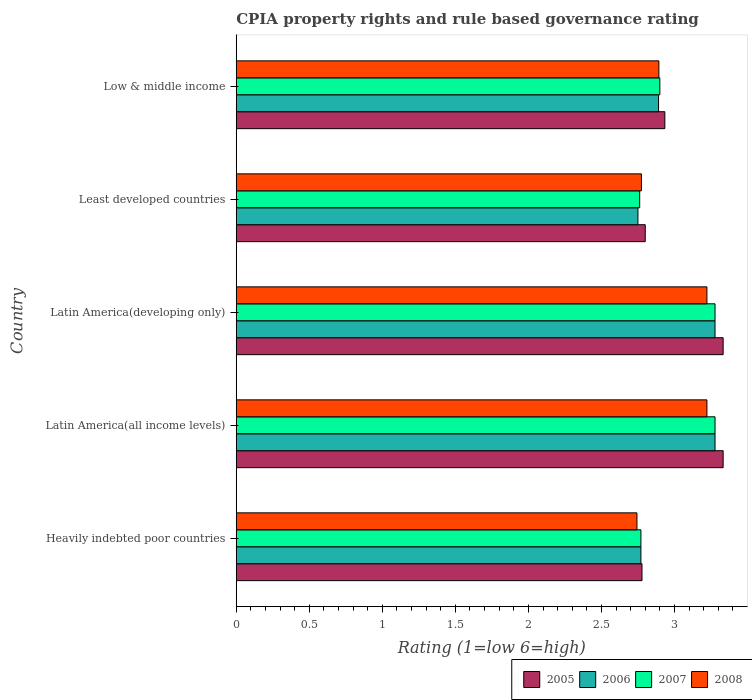How many different coloured bars are there?
Provide a short and direct response. 4. How many groups of bars are there?
Keep it short and to the point. 5. Are the number of bars on each tick of the Y-axis equal?
Provide a short and direct response. Yes. How many bars are there on the 2nd tick from the top?
Provide a short and direct response. 4. How many bars are there on the 3rd tick from the bottom?
Offer a terse response. 4. What is the label of the 4th group of bars from the top?
Keep it short and to the point. Latin America(all income levels). In how many cases, is the number of bars for a given country not equal to the number of legend labels?
Ensure brevity in your answer.  0. What is the CPIA rating in 2006 in Latin America(all income levels)?
Provide a succinct answer. 3.28. Across all countries, what is the maximum CPIA rating in 2006?
Offer a very short reply. 3.28. Across all countries, what is the minimum CPIA rating in 2006?
Provide a short and direct response. 2.75. In which country was the CPIA rating in 2006 maximum?
Your response must be concise. Latin America(all income levels). In which country was the CPIA rating in 2007 minimum?
Offer a terse response. Least developed countries. What is the total CPIA rating in 2006 in the graph?
Your answer should be compact. 14.97. What is the difference between the CPIA rating in 2005 in Heavily indebted poor countries and that in Latin America(developing only)?
Give a very brief answer. -0.56. What is the difference between the CPIA rating in 2005 in Heavily indebted poor countries and the CPIA rating in 2006 in Latin America(developing only)?
Your answer should be very brief. -0.5. What is the average CPIA rating in 2006 per country?
Your answer should be very brief. 2.99. What is the difference between the CPIA rating in 2005 and CPIA rating in 2008 in Latin America(all income levels)?
Provide a short and direct response. 0.11. In how many countries, is the CPIA rating in 2006 greater than 2.5 ?
Provide a succinct answer. 5. What is the ratio of the CPIA rating in 2005 in Heavily indebted poor countries to that in Latin America(developing only)?
Give a very brief answer. 0.83. Is the CPIA rating in 2008 in Latin America(developing only) less than that in Least developed countries?
Keep it short and to the point. No. Is the difference between the CPIA rating in 2005 in Least developed countries and Low & middle income greater than the difference between the CPIA rating in 2008 in Least developed countries and Low & middle income?
Your answer should be compact. No. What is the difference between the highest and the lowest CPIA rating in 2007?
Your answer should be compact. 0.52. Is the sum of the CPIA rating in 2005 in Latin America(all income levels) and Latin America(developing only) greater than the maximum CPIA rating in 2008 across all countries?
Your response must be concise. Yes. Is it the case that in every country, the sum of the CPIA rating in 2006 and CPIA rating in 2008 is greater than the sum of CPIA rating in 2005 and CPIA rating in 2007?
Your answer should be very brief. No. Is it the case that in every country, the sum of the CPIA rating in 2005 and CPIA rating in 2006 is greater than the CPIA rating in 2008?
Offer a very short reply. Yes. How many bars are there?
Provide a succinct answer. 20. How many countries are there in the graph?
Ensure brevity in your answer.  5. Are the values on the major ticks of X-axis written in scientific E-notation?
Ensure brevity in your answer.  No. Does the graph contain grids?
Offer a terse response. No. How many legend labels are there?
Your response must be concise. 4. How are the legend labels stacked?
Ensure brevity in your answer.  Horizontal. What is the title of the graph?
Make the answer very short. CPIA property rights and rule based governance rating. Does "1994" appear as one of the legend labels in the graph?
Offer a very short reply. No. What is the label or title of the X-axis?
Provide a succinct answer. Rating (1=low 6=high). What is the Rating (1=low 6=high) of 2005 in Heavily indebted poor countries?
Give a very brief answer. 2.78. What is the Rating (1=low 6=high) in 2006 in Heavily indebted poor countries?
Give a very brief answer. 2.77. What is the Rating (1=low 6=high) in 2007 in Heavily indebted poor countries?
Provide a succinct answer. 2.77. What is the Rating (1=low 6=high) in 2008 in Heavily indebted poor countries?
Your answer should be compact. 2.74. What is the Rating (1=low 6=high) in 2005 in Latin America(all income levels)?
Offer a terse response. 3.33. What is the Rating (1=low 6=high) in 2006 in Latin America(all income levels)?
Your answer should be very brief. 3.28. What is the Rating (1=low 6=high) of 2007 in Latin America(all income levels)?
Offer a terse response. 3.28. What is the Rating (1=low 6=high) in 2008 in Latin America(all income levels)?
Ensure brevity in your answer.  3.22. What is the Rating (1=low 6=high) of 2005 in Latin America(developing only)?
Your response must be concise. 3.33. What is the Rating (1=low 6=high) in 2006 in Latin America(developing only)?
Your answer should be very brief. 3.28. What is the Rating (1=low 6=high) of 2007 in Latin America(developing only)?
Offer a terse response. 3.28. What is the Rating (1=low 6=high) of 2008 in Latin America(developing only)?
Your response must be concise. 3.22. What is the Rating (1=low 6=high) of 2005 in Least developed countries?
Your response must be concise. 2.8. What is the Rating (1=low 6=high) in 2006 in Least developed countries?
Your answer should be compact. 2.75. What is the Rating (1=low 6=high) in 2007 in Least developed countries?
Offer a terse response. 2.76. What is the Rating (1=low 6=high) in 2008 in Least developed countries?
Offer a terse response. 2.77. What is the Rating (1=low 6=high) in 2005 in Low & middle income?
Ensure brevity in your answer.  2.93. What is the Rating (1=low 6=high) in 2006 in Low & middle income?
Your answer should be compact. 2.89. What is the Rating (1=low 6=high) in 2008 in Low & middle income?
Offer a terse response. 2.89. Across all countries, what is the maximum Rating (1=low 6=high) of 2005?
Offer a very short reply. 3.33. Across all countries, what is the maximum Rating (1=low 6=high) of 2006?
Offer a terse response. 3.28. Across all countries, what is the maximum Rating (1=low 6=high) in 2007?
Provide a succinct answer. 3.28. Across all countries, what is the maximum Rating (1=low 6=high) in 2008?
Offer a terse response. 3.22. Across all countries, what is the minimum Rating (1=low 6=high) in 2005?
Ensure brevity in your answer.  2.78. Across all countries, what is the minimum Rating (1=low 6=high) in 2006?
Provide a succinct answer. 2.75. Across all countries, what is the minimum Rating (1=low 6=high) of 2007?
Your answer should be compact. 2.76. Across all countries, what is the minimum Rating (1=low 6=high) in 2008?
Your answer should be compact. 2.74. What is the total Rating (1=low 6=high) in 2005 in the graph?
Give a very brief answer. 15.18. What is the total Rating (1=low 6=high) of 2006 in the graph?
Provide a short and direct response. 14.97. What is the total Rating (1=low 6=high) in 2007 in the graph?
Offer a terse response. 14.99. What is the total Rating (1=low 6=high) in 2008 in the graph?
Your answer should be very brief. 14.85. What is the difference between the Rating (1=low 6=high) in 2005 in Heavily indebted poor countries and that in Latin America(all income levels)?
Provide a succinct answer. -0.56. What is the difference between the Rating (1=low 6=high) in 2006 in Heavily indebted poor countries and that in Latin America(all income levels)?
Keep it short and to the point. -0.51. What is the difference between the Rating (1=low 6=high) in 2007 in Heavily indebted poor countries and that in Latin America(all income levels)?
Offer a very short reply. -0.51. What is the difference between the Rating (1=low 6=high) in 2008 in Heavily indebted poor countries and that in Latin America(all income levels)?
Your answer should be compact. -0.48. What is the difference between the Rating (1=low 6=high) of 2005 in Heavily indebted poor countries and that in Latin America(developing only)?
Make the answer very short. -0.56. What is the difference between the Rating (1=low 6=high) in 2006 in Heavily indebted poor countries and that in Latin America(developing only)?
Keep it short and to the point. -0.51. What is the difference between the Rating (1=low 6=high) in 2007 in Heavily indebted poor countries and that in Latin America(developing only)?
Your answer should be compact. -0.51. What is the difference between the Rating (1=low 6=high) of 2008 in Heavily indebted poor countries and that in Latin America(developing only)?
Keep it short and to the point. -0.48. What is the difference between the Rating (1=low 6=high) of 2005 in Heavily indebted poor countries and that in Least developed countries?
Offer a very short reply. -0.02. What is the difference between the Rating (1=low 6=high) of 2006 in Heavily indebted poor countries and that in Least developed countries?
Provide a succinct answer. 0.02. What is the difference between the Rating (1=low 6=high) of 2007 in Heavily indebted poor countries and that in Least developed countries?
Your answer should be very brief. 0.01. What is the difference between the Rating (1=low 6=high) of 2008 in Heavily indebted poor countries and that in Least developed countries?
Offer a terse response. -0.03. What is the difference between the Rating (1=low 6=high) of 2005 in Heavily indebted poor countries and that in Low & middle income?
Your answer should be very brief. -0.16. What is the difference between the Rating (1=low 6=high) of 2006 in Heavily indebted poor countries and that in Low & middle income?
Ensure brevity in your answer.  -0.12. What is the difference between the Rating (1=low 6=high) in 2007 in Heavily indebted poor countries and that in Low & middle income?
Make the answer very short. -0.13. What is the difference between the Rating (1=low 6=high) in 2008 in Heavily indebted poor countries and that in Low & middle income?
Provide a short and direct response. -0.15. What is the difference between the Rating (1=low 6=high) of 2005 in Latin America(all income levels) and that in Latin America(developing only)?
Offer a very short reply. 0. What is the difference between the Rating (1=low 6=high) of 2006 in Latin America(all income levels) and that in Latin America(developing only)?
Provide a short and direct response. 0. What is the difference between the Rating (1=low 6=high) in 2007 in Latin America(all income levels) and that in Latin America(developing only)?
Give a very brief answer. 0. What is the difference between the Rating (1=low 6=high) of 2005 in Latin America(all income levels) and that in Least developed countries?
Ensure brevity in your answer.  0.53. What is the difference between the Rating (1=low 6=high) of 2006 in Latin America(all income levels) and that in Least developed countries?
Provide a succinct answer. 0.53. What is the difference between the Rating (1=low 6=high) of 2007 in Latin America(all income levels) and that in Least developed countries?
Offer a terse response. 0.52. What is the difference between the Rating (1=low 6=high) of 2008 in Latin America(all income levels) and that in Least developed countries?
Your answer should be compact. 0.45. What is the difference between the Rating (1=low 6=high) of 2005 in Latin America(all income levels) and that in Low & middle income?
Ensure brevity in your answer.  0.4. What is the difference between the Rating (1=low 6=high) of 2006 in Latin America(all income levels) and that in Low & middle income?
Give a very brief answer. 0.39. What is the difference between the Rating (1=low 6=high) of 2007 in Latin America(all income levels) and that in Low & middle income?
Your answer should be compact. 0.38. What is the difference between the Rating (1=low 6=high) in 2008 in Latin America(all income levels) and that in Low & middle income?
Make the answer very short. 0.33. What is the difference between the Rating (1=low 6=high) of 2005 in Latin America(developing only) and that in Least developed countries?
Provide a short and direct response. 0.53. What is the difference between the Rating (1=low 6=high) in 2006 in Latin America(developing only) and that in Least developed countries?
Your answer should be compact. 0.53. What is the difference between the Rating (1=low 6=high) in 2007 in Latin America(developing only) and that in Least developed countries?
Provide a succinct answer. 0.52. What is the difference between the Rating (1=low 6=high) of 2008 in Latin America(developing only) and that in Least developed countries?
Keep it short and to the point. 0.45. What is the difference between the Rating (1=low 6=high) of 2005 in Latin America(developing only) and that in Low & middle income?
Give a very brief answer. 0.4. What is the difference between the Rating (1=low 6=high) of 2006 in Latin America(developing only) and that in Low & middle income?
Offer a very short reply. 0.39. What is the difference between the Rating (1=low 6=high) of 2007 in Latin America(developing only) and that in Low & middle income?
Offer a very short reply. 0.38. What is the difference between the Rating (1=low 6=high) in 2008 in Latin America(developing only) and that in Low & middle income?
Make the answer very short. 0.33. What is the difference between the Rating (1=low 6=high) in 2005 in Least developed countries and that in Low & middle income?
Offer a terse response. -0.13. What is the difference between the Rating (1=low 6=high) of 2006 in Least developed countries and that in Low & middle income?
Your answer should be very brief. -0.14. What is the difference between the Rating (1=low 6=high) in 2007 in Least developed countries and that in Low & middle income?
Offer a very short reply. -0.14. What is the difference between the Rating (1=low 6=high) in 2008 in Least developed countries and that in Low & middle income?
Your response must be concise. -0.12. What is the difference between the Rating (1=low 6=high) of 2005 in Heavily indebted poor countries and the Rating (1=low 6=high) of 2007 in Latin America(all income levels)?
Your answer should be very brief. -0.5. What is the difference between the Rating (1=low 6=high) in 2005 in Heavily indebted poor countries and the Rating (1=low 6=high) in 2008 in Latin America(all income levels)?
Offer a very short reply. -0.44. What is the difference between the Rating (1=low 6=high) in 2006 in Heavily indebted poor countries and the Rating (1=low 6=high) in 2007 in Latin America(all income levels)?
Offer a very short reply. -0.51. What is the difference between the Rating (1=low 6=high) of 2006 in Heavily indebted poor countries and the Rating (1=low 6=high) of 2008 in Latin America(all income levels)?
Your answer should be very brief. -0.45. What is the difference between the Rating (1=low 6=high) in 2007 in Heavily indebted poor countries and the Rating (1=low 6=high) in 2008 in Latin America(all income levels)?
Offer a terse response. -0.45. What is the difference between the Rating (1=low 6=high) in 2005 in Heavily indebted poor countries and the Rating (1=low 6=high) in 2007 in Latin America(developing only)?
Give a very brief answer. -0.5. What is the difference between the Rating (1=low 6=high) in 2005 in Heavily indebted poor countries and the Rating (1=low 6=high) in 2008 in Latin America(developing only)?
Give a very brief answer. -0.44. What is the difference between the Rating (1=low 6=high) of 2006 in Heavily indebted poor countries and the Rating (1=low 6=high) of 2007 in Latin America(developing only)?
Provide a succinct answer. -0.51. What is the difference between the Rating (1=low 6=high) in 2006 in Heavily indebted poor countries and the Rating (1=low 6=high) in 2008 in Latin America(developing only)?
Your response must be concise. -0.45. What is the difference between the Rating (1=low 6=high) of 2007 in Heavily indebted poor countries and the Rating (1=low 6=high) of 2008 in Latin America(developing only)?
Offer a very short reply. -0.45. What is the difference between the Rating (1=low 6=high) of 2005 in Heavily indebted poor countries and the Rating (1=low 6=high) of 2006 in Least developed countries?
Provide a succinct answer. 0.03. What is the difference between the Rating (1=low 6=high) in 2005 in Heavily indebted poor countries and the Rating (1=low 6=high) in 2007 in Least developed countries?
Ensure brevity in your answer.  0.02. What is the difference between the Rating (1=low 6=high) in 2005 in Heavily indebted poor countries and the Rating (1=low 6=high) in 2008 in Least developed countries?
Ensure brevity in your answer.  0. What is the difference between the Rating (1=low 6=high) in 2006 in Heavily indebted poor countries and the Rating (1=low 6=high) in 2007 in Least developed countries?
Keep it short and to the point. 0.01. What is the difference between the Rating (1=low 6=high) of 2006 in Heavily indebted poor countries and the Rating (1=low 6=high) of 2008 in Least developed countries?
Make the answer very short. -0. What is the difference between the Rating (1=low 6=high) in 2007 in Heavily indebted poor countries and the Rating (1=low 6=high) in 2008 in Least developed countries?
Ensure brevity in your answer.  -0. What is the difference between the Rating (1=low 6=high) of 2005 in Heavily indebted poor countries and the Rating (1=low 6=high) of 2006 in Low & middle income?
Your answer should be very brief. -0.11. What is the difference between the Rating (1=low 6=high) of 2005 in Heavily indebted poor countries and the Rating (1=low 6=high) of 2007 in Low & middle income?
Provide a short and direct response. -0.12. What is the difference between the Rating (1=low 6=high) of 2005 in Heavily indebted poor countries and the Rating (1=low 6=high) of 2008 in Low & middle income?
Ensure brevity in your answer.  -0.12. What is the difference between the Rating (1=low 6=high) in 2006 in Heavily indebted poor countries and the Rating (1=low 6=high) in 2007 in Low & middle income?
Ensure brevity in your answer.  -0.13. What is the difference between the Rating (1=low 6=high) of 2006 in Heavily indebted poor countries and the Rating (1=low 6=high) of 2008 in Low & middle income?
Keep it short and to the point. -0.12. What is the difference between the Rating (1=low 6=high) in 2007 in Heavily indebted poor countries and the Rating (1=low 6=high) in 2008 in Low & middle income?
Provide a short and direct response. -0.12. What is the difference between the Rating (1=low 6=high) in 2005 in Latin America(all income levels) and the Rating (1=low 6=high) in 2006 in Latin America(developing only)?
Provide a short and direct response. 0.06. What is the difference between the Rating (1=low 6=high) in 2005 in Latin America(all income levels) and the Rating (1=low 6=high) in 2007 in Latin America(developing only)?
Make the answer very short. 0.06. What is the difference between the Rating (1=low 6=high) in 2005 in Latin America(all income levels) and the Rating (1=low 6=high) in 2008 in Latin America(developing only)?
Ensure brevity in your answer.  0.11. What is the difference between the Rating (1=low 6=high) in 2006 in Latin America(all income levels) and the Rating (1=low 6=high) in 2008 in Latin America(developing only)?
Offer a terse response. 0.06. What is the difference between the Rating (1=low 6=high) of 2007 in Latin America(all income levels) and the Rating (1=low 6=high) of 2008 in Latin America(developing only)?
Your answer should be compact. 0.06. What is the difference between the Rating (1=low 6=high) in 2005 in Latin America(all income levels) and the Rating (1=low 6=high) in 2006 in Least developed countries?
Offer a very short reply. 0.58. What is the difference between the Rating (1=low 6=high) of 2005 in Latin America(all income levels) and the Rating (1=low 6=high) of 2008 in Least developed countries?
Your answer should be very brief. 0.56. What is the difference between the Rating (1=low 6=high) of 2006 in Latin America(all income levels) and the Rating (1=low 6=high) of 2007 in Least developed countries?
Give a very brief answer. 0.52. What is the difference between the Rating (1=low 6=high) in 2006 in Latin America(all income levels) and the Rating (1=low 6=high) in 2008 in Least developed countries?
Give a very brief answer. 0.5. What is the difference between the Rating (1=low 6=high) of 2007 in Latin America(all income levels) and the Rating (1=low 6=high) of 2008 in Least developed countries?
Give a very brief answer. 0.5. What is the difference between the Rating (1=low 6=high) in 2005 in Latin America(all income levels) and the Rating (1=low 6=high) in 2006 in Low & middle income?
Your answer should be very brief. 0.44. What is the difference between the Rating (1=low 6=high) in 2005 in Latin America(all income levels) and the Rating (1=low 6=high) in 2007 in Low & middle income?
Provide a succinct answer. 0.43. What is the difference between the Rating (1=low 6=high) of 2005 in Latin America(all income levels) and the Rating (1=low 6=high) of 2008 in Low & middle income?
Ensure brevity in your answer.  0.44. What is the difference between the Rating (1=low 6=high) in 2006 in Latin America(all income levels) and the Rating (1=low 6=high) in 2007 in Low & middle income?
Provide a short and direct response. 0.38. What is the difference between the Rating (1=low 6=high) in 2006 in Latin America(all income levels) and the Rating (1=low 6=high) in 2008 in Low & middle income?
Your answer should be compact. 0.38. What is the difference between the Rating (1=low 6=high) of 2007 in Latin America(all income levels) and the Rating (1=low 6=high) of 2008 in Low & middle income?
Make the answer very short. 0.38. What is the difference between the Rating (1=low 6=high) of 2005 in Latin America(developing only) and the Rating (1=low 6=high) of 2006 in Least developed countries?
Offer a terse response. 0.58. What is the difference between the Rating (1=low 6=high) in 2005 in Latin America(developing only) and the Rating (1=low 6=high) in 2008 in Least developed countries?
Make the answer very short. 0.56. What is the difference between the Rating (1=low 6=high) in 2006 in Latin America(developing only) and the Rating (1=low 6=high) in 2007 in Least developed countries?
Give a very brief answer. 0.52. What is the difference between the Rating (1=low 6=high) in 2006 in Latin America(developing only) and the Rating (1=low 6=high) in 2008 in Least developed countries?
Keep it short and to the point. 0.5. What is the difference between the Rating (1=low 6=high) of 2007 in Latin America(developing only) and the Rating (1=low 6=high) of 2008 in Least developed countries?
Provide a succinct answer. 0.5. What is the difference between the Rating (1=low 6=high) in 2005 in Latin America(developing only) and the Rating (1=low 6=high) in 2006 in Low & middle income?
Provide a succinct answer. 0.44. What is the difference between the Rating (1=low 6=high) of 2005 in Latin America(developing only) and the Rating (1=low 6=high) of 2007 in Low & middle income?
Your answer should be compact. 0.43. What is the difference between the Rating (1=low 6=high) in 2005 in Latin America(developing only) and the Rating (1=low 6=high) in 2008 in Low & middle income?
Your answer should be very brief. 0.44. What is the difference between the Rating (1=low 6=high) of 2006 in Latin America(developing only) and the Rating (1=low 6=high) of 2007 in Low & middle income?
Your answer should be very brief. 0.38. What is the difference between the Rating (1=low 6=high) of 2006 in Latin America(developing only) and the Rating (1=low 6=high) of 2008 in Low & middle income?
Provide a succinct answer. 0.38. What is the difference between the Rating (1=low 6=high) in 2007 in Latin America(developing only) and the Rating (1=low 6=high) in 2008 in Low & middle income?
Give a very brief answer. 0.38. What is the difference between the Rating (1=low 6=high) in 2005 in Least developed countries and the Rating (1=low 6=high) in 2006 in Low & middle income?
Offer a very short reply. -0.09. What is the difference between the Rating (1=low 6=high) in 2005 in Least developed countries and the Rating (1=low 6=high) in 2007 in Low & middle income?
Your answer should be compact. -0.1. What is the difference between the Rating (1=low 6=high) in 2005 in Least developed countries and the Rating (1=low 6=high) in 2008 in Low & middle income?
Provide a succinct answer. -0.09. What is the difference between the Rating (1=low 6=high) of 2006 in Least developed countries and the Rating (1=low 6=high) of 2007 in Low & middle income?
Provide a succinct answer. -0.15. What is the difference between the Rating (1=low 6=high) in 2006 in Least developed countries and the Rating (1=low 6=high) in 2008 in Low & middle income?
Your response must be concise. -0.14. What is the difference between the Rating (1=low 6=high) of 2007 in Least developed countries and the Rating (1=low 6=high) of 2008 in Low & middle income?
Offer a very short reply. -0.13. What is the average Rating (1=low 6=high) in 2005 per country?
Offer a terse response. 3.04. What is the average Rating (1=low 6=high) in 2006 per country?
Offer a terse response. 2.99. What is the average Rating (1=low 6=high) in 2007 per country?
Ensure brevity in your answer.  3. What is the average Rating (1=low 6=high) of 2008 per country?
Keep it short and to the point. 2.97. What is the difference between the Rating (1=low 6=high) in 2005 and Rating (1=low 6=high) in 2006 in Heavily indebted poor countries?
Give a very brief answer. 0.01. What is the difference between the Rating (1=low 6=high) of 2005 and Rating (1=low 6=high) of 2007 in Heavily indebted poor countries?
Your answer should be very brief. 0.01. What is the difference between the Rating (1=low 6=high) of 2005 and Rating (1=low 6=high) of 2008 in Heavily indebted poor countries?
Your answer should be very brief. 0.03. What is the difference between the Rating (1=low 6=high) in 2006 and Rating (1=low 6=high) in 2008 in Heavily indebted poor countries?
Your answer should be very brief. 0.03. What is the difference between the Rating (1=low 6=high) of 2007 and Rating (1=low 6=high) of 2008 in Heavily indebted poor countries?
Give a very brief answer. 0.03. What is the difference between the Rating (1=low 6=high) in 2005 and Rating (1=low 6=high) in 2006 in Latin America(all income levels)?
Offer a terse response. 0.06. What is the difference between the Rating (1=low 6=high) of 2005 and Rating (1=low 6=high) of 2007 in Latin America(all income levels)?
Give a very brief answer. 0.06. What is the difference between the Rating (1=low 6=high) of 2005 and Rating (1=low 6=high) of 2008 in Latin America(all income levels)?
Make the answer very short. 0.11. What is the difference between the Rating (1=low 6=high) of 2006 and Rating (1=low 6=high) of 2007 in Latin America(all income levels)?
Offer a very short reply. 0. What is the difference between the Rating (1=low 6=high) in 2006 and Rating (1=low 6=high) in 2008 in Latin America(all income levels)?
Offer a terse response. 0.06. What is the difference between the Rating (1=low 6=high) in 2007 and Rating (1=low 6=high) in 2008 in Latin America(all income levels)?
Offer a terse response. 0.06. What is the difference between the Rating (1=low 6=high) in 2005 and Rating (1=low 6=high) in 2006 in Latin America(developing only)?
Give a very brief answer. 0.06. What is the difference between the Rating (1=low 6=high) of 2005 and Rating (1=low 6=high) of 2007 in Latin America(developing only)?
Offer a very short reply. 0.06. What is the difference between the Rating (1=low 6=high) of 2006 and Rating (1=low 6=high) of 2008 in Latin America(developing only)?
Offer a very short reply. 0.06. What is the difference between the Rating (1=low 6=high) of 2007 and Rating (1=low 6=high) of 2008 in Latin America(developing only)?
Provide a short and direct response. 0.06. What is the difference between the Rating (1=low 6=high) of 2005 and Rating (1=low 6=high) of 2006 in Least developed countries?
Provide a succinct answer. 0.05. What is the difference between the Rating (1=low 6=high) of 2005 and Rating (1=low 6=high) of 2007 in Least developed countries?
Give a very brief answer. 0.04. What is the difference between the Rating (1=low 6=high) in 2005 and Rating (1=low 6=high) in 2008 in Least developed countries?
Make the answer very short. 0.03. What is the difference between the Rating (1=low 6=high) in 2006 and Rating (1=low 6=high) in 2007 in Least developed countries?
Give a very brief answer. -0.01. What is the difference between the Rating (1=low 6=high) of 2006 and Rating (1=low 6=high) of 2008 in Least developed countries?
Your answer should be very brief. -0.02. What is the difference between the Rating (1=low 6=high) of 2007 and Rating (1=low 6=high) of 2008 in Least developed countries?
Provide a short and direct response. -0.01. What is the difference between the Rating (1=low 6=high) in 2005 and Rating (1=low 6=high) in 2006 in Low & middle income?
Make the answer very short. 0.04. What is the difference between the Rating (1=low 6=high) in 2005 and Rating (1=low 6=high) in 2007 in Low & middle income?
Keep it short and to the point. 0.03. What is the difference between the Rating (1=low 6=high) in 2005 and Rating (1=low 6=high) in 2008 in Low & middle income?
Your answer should be very brief. 0.04. What is the difference between the Rating (1=low 6=high) in 2006 and Rating (1=low 6=high) in 2007 in Low & middle income?
Your answer should be very brief. -0.01. What is the difference between the Rating (1=low 6=high) in 2006 and Rating (1=low 6=high) in 2008 in Low & middle income?
Your answer should be very brief. -0. What is the difference between the Rating (1=low 6=high) in 2007 and Rating (1=low 6=high) in 2008 in Low & middle income?
Offer a terse response. 0.01. What is the ratio of the Rating (1=low 6=high) of 2005 in Heavily indebted poor countries to that in Latin America(all income levels)?
Make the answer very short. 0.83. What is the ratio of the Rating (1=low 6=high) in 2006 in Heavily indebted poor countries to that in Latin America(all income levels)?
Offer a very short reply. 0.85. What is the ratio of the Rating (1=low 6=high) in 2007 in Heavily indebted poor countries to that in Latin America(all income levels)?
Ensure brevity in your answer.  0.85. What is the ratio of the Rating (1=low 6=high) of 2008 in Heavily indebted poor countries to that in Latin America(all income levels)?
Offer a very short reply. 0.85. What is the ratio of the Rating (1=low 6=high) of 2005 in Heavily indebted poor countries to that in Latin America(developing only)?
Keep it short and to the point. 0.83. What is the ratio of the Rating (1=low 6=high) in 2006 in Heavily indebted poor countries to that in Latin America(developing only)?
Ensure brevity in your answer.  0.85. What is the ratio of the Rating (1=low 6=high) of 2007 in Heavily indebted poor countries to that in Latin America(developing only)?
Offer a terse response. 0.85. What is the ratio of the Rating (1=low 6=high) of 2008 in Heavily indebted poor countries to that in Latin America(developing only)?
Make the answer very short. 0.85. What is the ratio of the Rating (1=low 6=high) of 2006 in Heavily indebted poor countries to that in Least developed countries?
Give a very brief answer. 1.01. What is the ratio of the Rating (1=low 6=high) of 2005 in Heavily indebted poor countries to that in Low & middle income?
Give a very brief answer. 0.95. What is the ratio of the Rating (1=low 6=high) of 2006 in Heavily indebted poor countries to that in Low & middle income?
Your answer should be very brief. 0.96. What is the ratio of the Rating (1=low 6=high) in 2007 in Heavily indebted poor countries to that in Low & middle income?
Your answer should be very brief. 0.96. What is the ratio of the Rating (1=low 6=high) of 2008 in Heavily indebted poor countries to that in Low & middle income?
Your answer should be very brief. 0.95. What is the ratio of the Rating (1=low 6=high) of 2007 in Latin America(all income levels) to that in Latin America(developing only)?
Provide a succinct answer. 1. What is the ratio of the Rating (1=low 6=high) in 2008 in Latin America(all income levels) to that in Latin America(developing only)?
Offer a terse response. 1. What is the ratio of the Rating (1=low 6=high) in 2005 in Latin America(all income levels) to that in Least developed countries?
Keep it short and to the point. 1.19. What is the ratio of the Rating (1=low 6=high) of 2006 in Latin America(all income levels) to that in Least developed countries?
Your answer should be very brief. 1.19. What is the ratio of the Rating (1=low 6=high) of 2007 in Latin America(all income levels) to that in Least developed countries?
Your answer should be very brief. 1.19. What is the ratio of the Rating (1=low 6=high) in 2008 in Latin America(all income levels) to that in Least developed countries?
Provide a short and direct response. 1.16. What is the ratio of the Rating (1=low 6=high) in 2005 in Latin America(all income levels) to that in Low & middle income?
Keep it short and to the point. 1.14. What is the ratio of the Rating (1=low 6=high) of 2006 in Latin America(all income levels) to that in Low & middle income?
Your answer should be compact. 1.13. What is the ratio of the Rating (1=low 6=high) in 2007 in Latin America(all income levels) to that in Low & middle income?
Your answer should be very brief. 1.13. What is the ratio of the Rating (1=low 6=high) in 2008 in Latin America(all income levels) to that in Low & middle income?
Make the answer very short. 1.11. What is the ratio of the Rating (1=low 6=high) in 2005 in Latin America(developing only) to that in Least developed countries?
Provide a short and direct response. 1.19. What is the ratio of the Rating (1=low 6=high) of 2006 in Latin America(developing only) to that in Least developed countries?
Make the answer very short. 1.19. What is the ratio of the Rating (1=low 6=high) of 2007 in Latin America(developing only) to that in Least developed countries?
Keep it short and to the point. 1.19. What is the ratio of the Rating (1=low 6=high) in 2008 in Latin America(developing only) to that in Least developed countries?
Your answer should be compact. 1.16. What is the ratio of the Rating (1=low 6=high) in 2005 in Latin America(developing only) to that in Low & middle income?
Your answer should be very brief. 1.14. What is the ratio of the Rating (1=low 6=high) of 2006 in Latin America(developing only) to that in Low & middle income?
Ensure brevity in your answer.  1.13. What is the ratio of the Rating (1=low 6=high) of 2007 in Latin America(developing only) to that in Low & middle income?
Keep it short and to the point. 1.13. What is the ratio of the Rating (1=low 6=high) of 2008 in Latin America(developing only) to that in Low & middle income?
Your answer should be compact. 1.11. What is the ratio of the Rating (1=low 6=high) in 2005 in Least developed countries to that in Low & middle income?
Offer a very short reply. 0.95. What is the ratio of the Rating (1=low 6=high) in 2006 in Least developed countries to that in Low & middle income?
Give a very brief answer. 0.95. What is the ratio of the Rating (1=low 6=high) of 2007 in Least developed countries to that in Low & middle income?
Provide a succinct answer. 0.95. What is the ratio of the Rating (1=low 6=high) in 2008 in Least developed countries to that in Low & middle income?
Ensure brevity in your answer.  0.96. What is the difference between the highest and the second highest Rating (1=low 6=high) in 2007?
Ensure brevity in your answer.  0. What is the difference between the highest and the lowest Rating (1=low 6=high) in 2005?
Your response must be concise. 0.56. What is the difference between the highest and the lowest Rating (1=low 6=high) in 2006?
Offer a very short reply. 0.53. What is the difference between the highest and the lowest Rating (1=low 6=high) of 2007?
Your answer should be compact. 0.52. What is the difference between the highest and the lowest Rating (1=low 6=high) of 2008?
Ensure brevity in your answer.  0.48. 